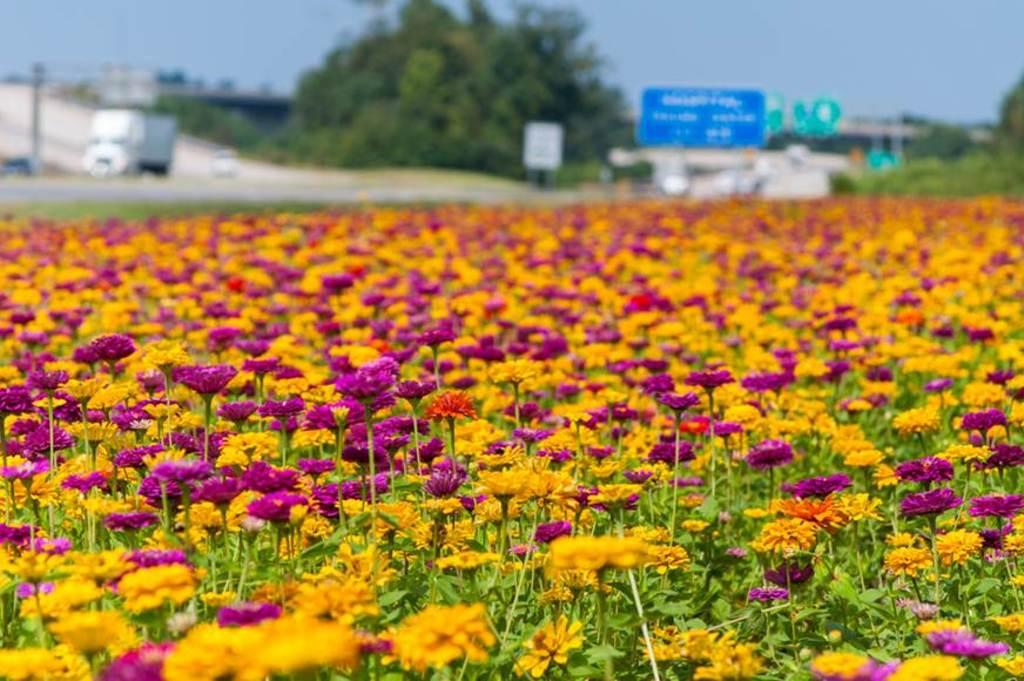What type of plants can be seen in the image? There are flowers in the image. What other natural elements are present in the image? There is a tree in the image. What man-made object can be seen in the image? There is a blue sign board in the image. What is visible at the top of the image? The sky is visible at the top of the image. What type of addition problem can be solved using the numbers on the tree in the image? There are no numbers or addition problems present on the tree in the image. What type of precipitation is falling from the sky in the image? The sky is visible in the image, but there is no indication of any precipitation, such as sleet. 